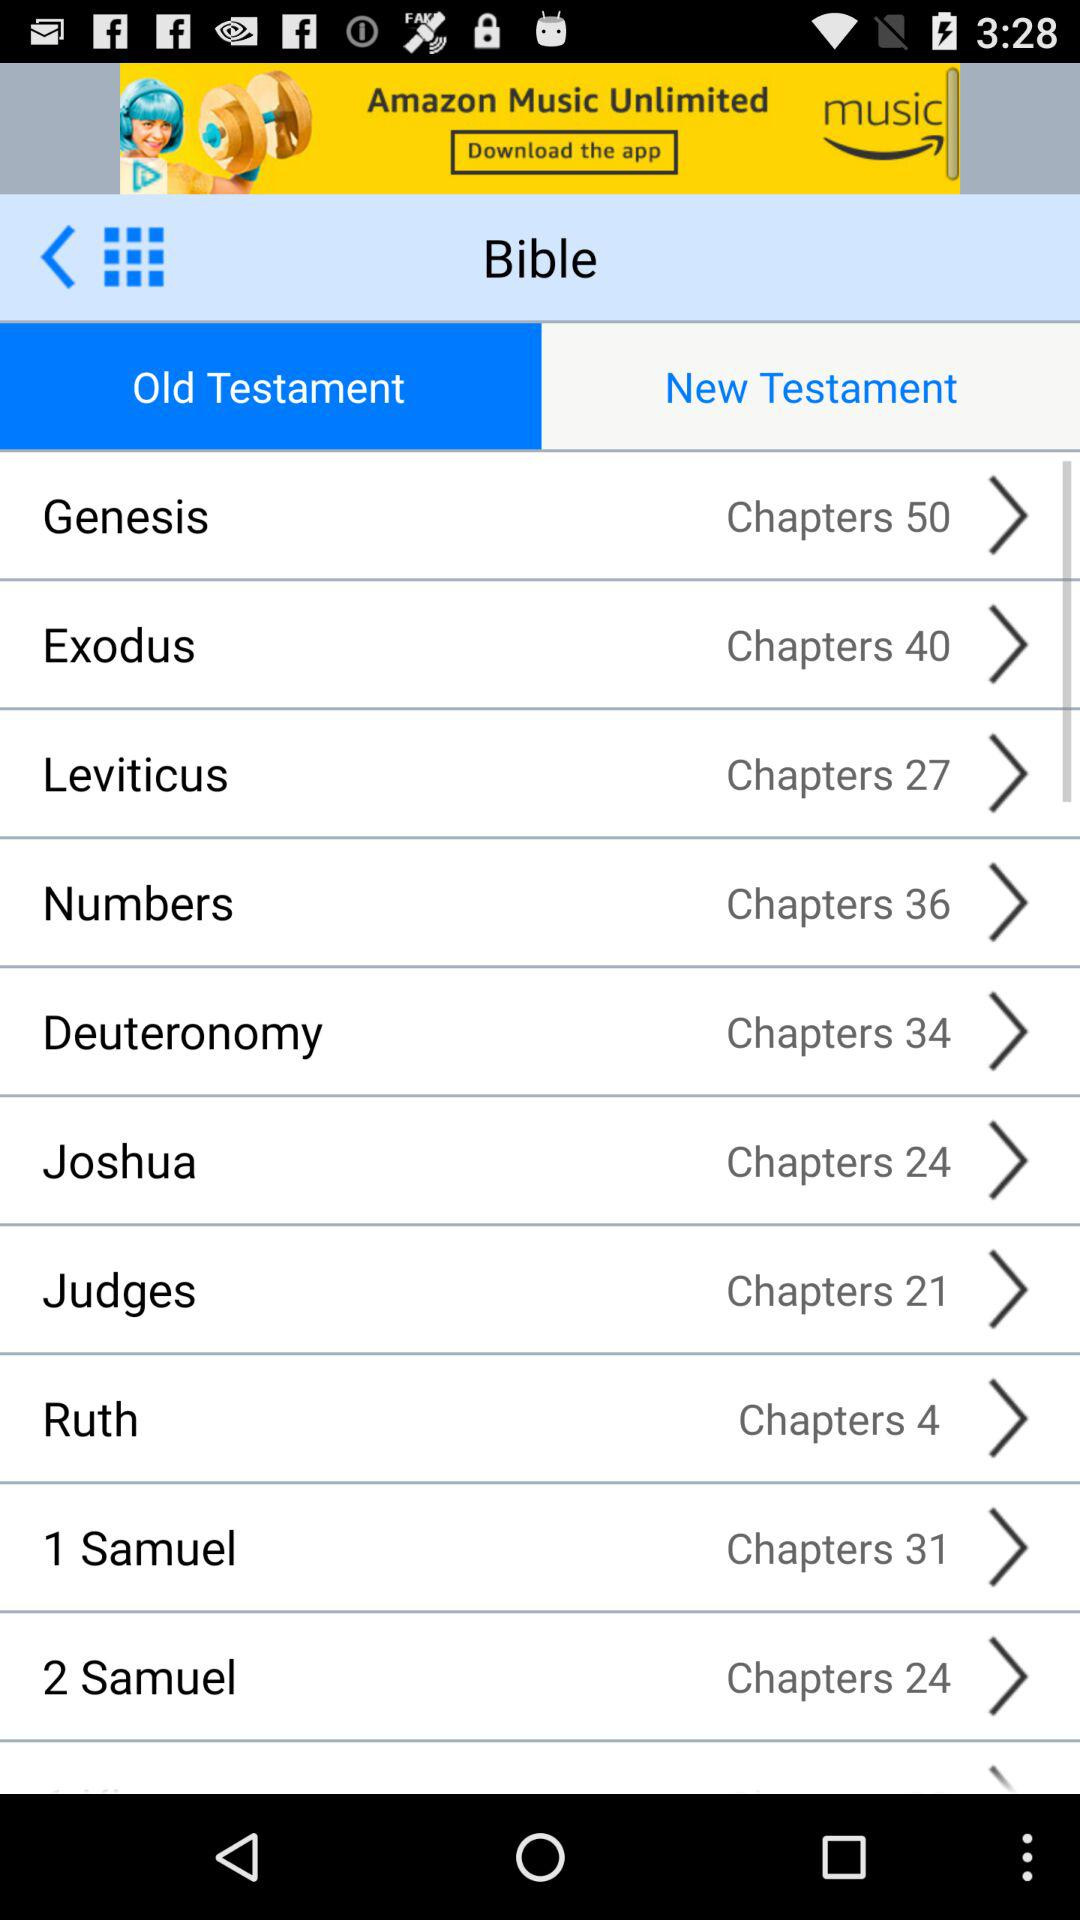How many chapters are available in "Leviticus"? There are 27 chapters available in "Leviticus". 